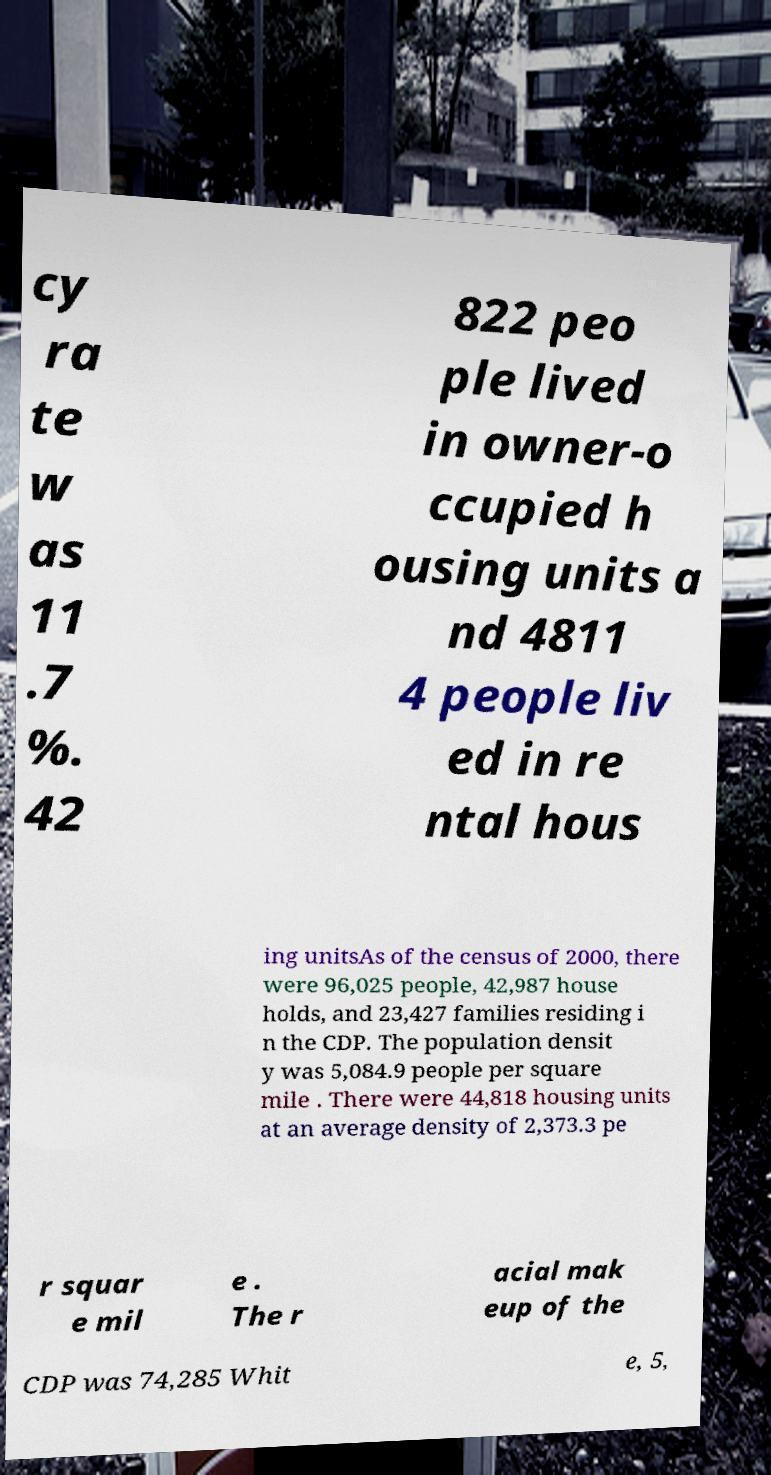Can you accurately transcribe the text from the provided image for me? cy ra te w as 11 .7 %. 42 822 peo ple lived in owner-o ccupied h ousing units a nd 4811 4 people liv ed in re ntal hous ing unitsAs of the census of 2000, there were 96,025 people, 42,987 house holds, and 23,427 families residing i n the CDP. The population densit y was 5,084.9 people per square mile . There were 44,818 housing units at an average density of 2,373.3 pe r squar e mil e . The r acial mak eup of the CDP was 74,285 Whit e, 5, 